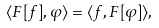<formula> <loc_0><loc_0><loc_500><loc_500>\langle F [ f ] , \varphi \rangle = \langle f , F [ \varphi ] \rangle ,</formula> 